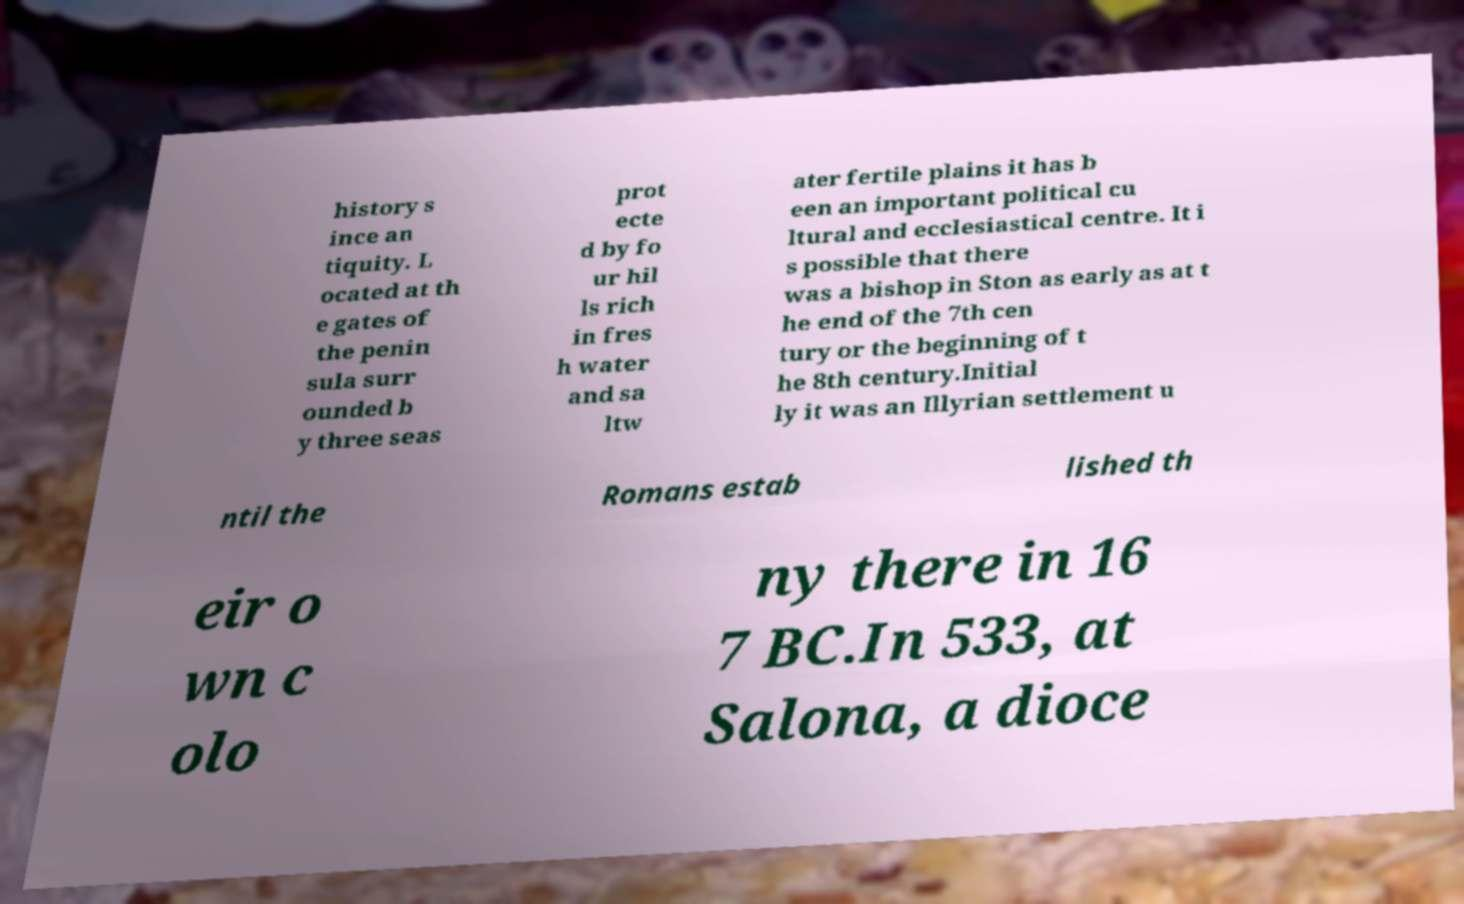Can you accurately transcribe the text from the provided image for me? history s ince an tiquity. L ocated at th e gates of the penin sula surr ounded b y three seas prot ecte d by fo ur hil ls rich in fres h water and sa ltw ater fertile plains it has b een an important political cu ltural and ecclesiastical centre. It i s possible that there was a bishop in Ston as early as at t he end of the 7th cen tury or the beginning of t he 8th century.Initial ly it was an Illyrian settlement u ntil the Romans estab lished th eir o wn c olo ny there in 16 7 BC.In 533, at Salona, a dioce 